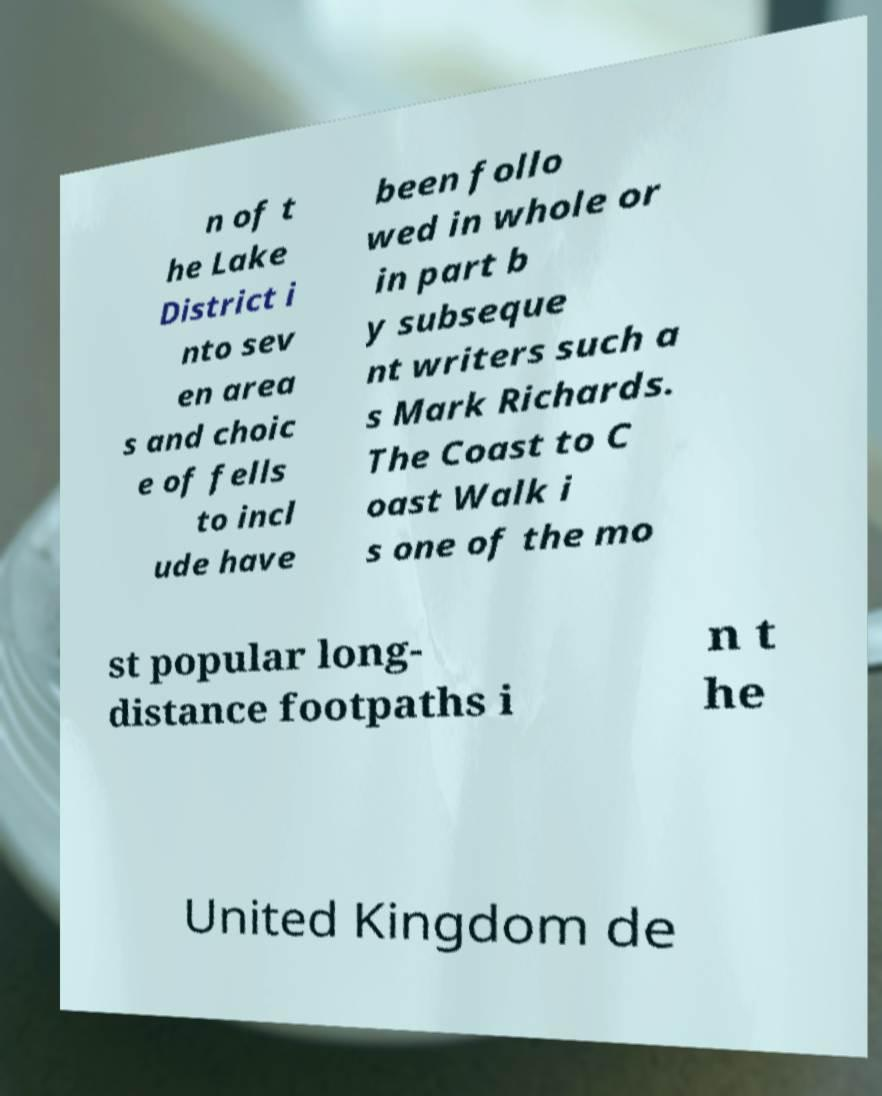Can you accurately transcribe the text from the provided image for me? n of t he Lake District i nto sev en area s and choic e of fells to incl ude have been follo wed in whole or in part b y subseque nt writers such a s Mark Richards. The Coast to C oast Walk i s one of the mo st popular long- distance footpaths i n t he United Kingdom de 